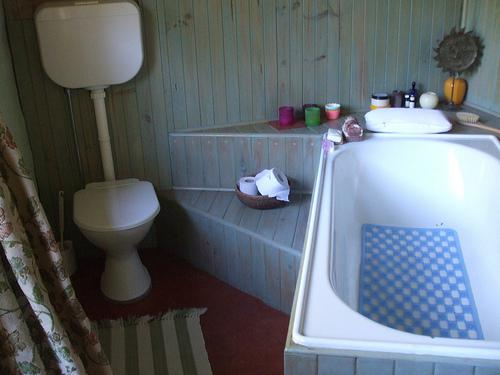Question: where was this photo taken?
Choices:
A. Ned's house.
B. Bathroom.
C. Greenhouse.
D. On the farm.
Answer with the letter. Answer: B Question: who is in the photo?
Choices:
A. Man.
B. Woman.
C. Noone.
D. Girl.
Answer with the letter. Answer: C Question: how is the photo?
Choices:
A. Sunny.
B. Cloudy.
C. Rainy.
D. Clear.
Answer with the letter. Answer: D 